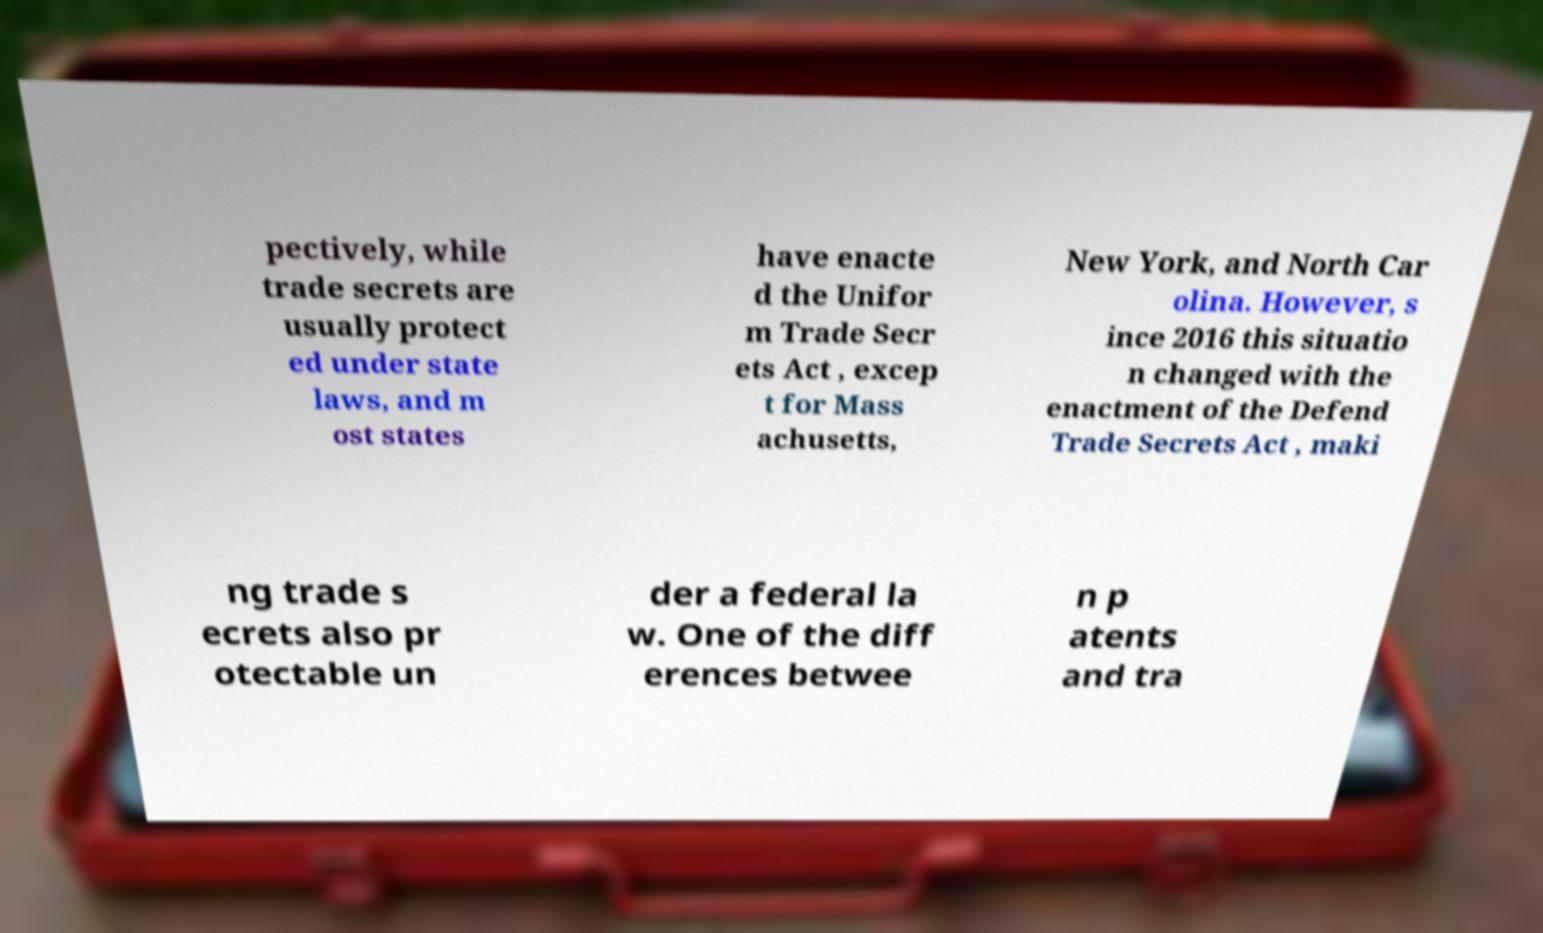Can you accurately transcribe the text from the provided image for me? pectively, while trade secrets are usually protect ed under state laws, and m ost states have enacte d the Unifor m Trade Secr ets Act , excep t for Mass achusetts, New York, and North Car olina. However, s ince 2016 this situatio n changed with the enactment of the Defend Trade Secrets Act , maki ng trade s ecrets also pr otectable un der a federal la w. One of the diff erences betwee n p atents and tra 